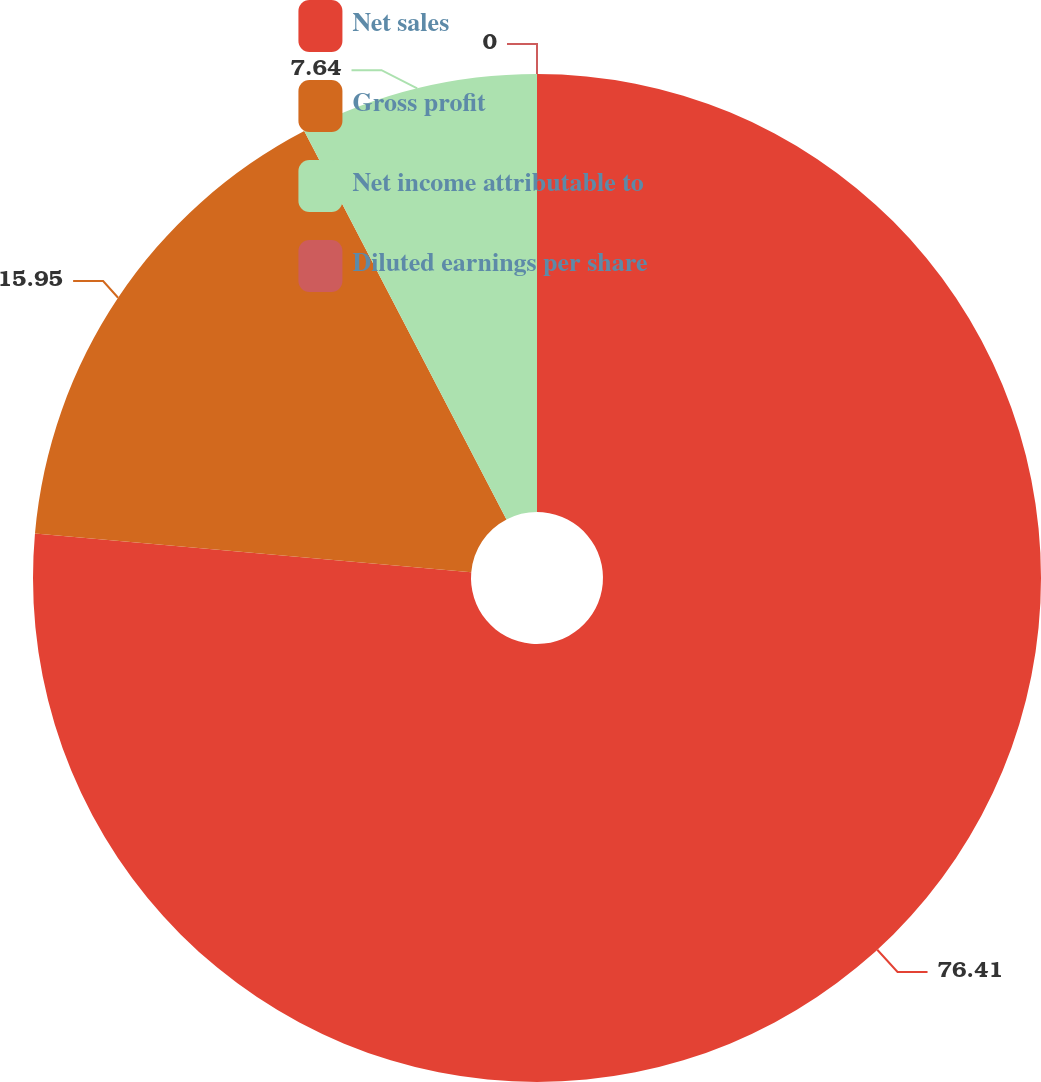<chart> <loc_0><loc_0><loc_500><loc_500><pie_chart><fcel>Net sales<fcel>Gross profit<fcel>Net income attributable to<fcel>Diluted earnings per share<nl><fcel>76.4%<fcel>15.95%<fcel>7.64%<fcel>0.0%<nl></chart> 